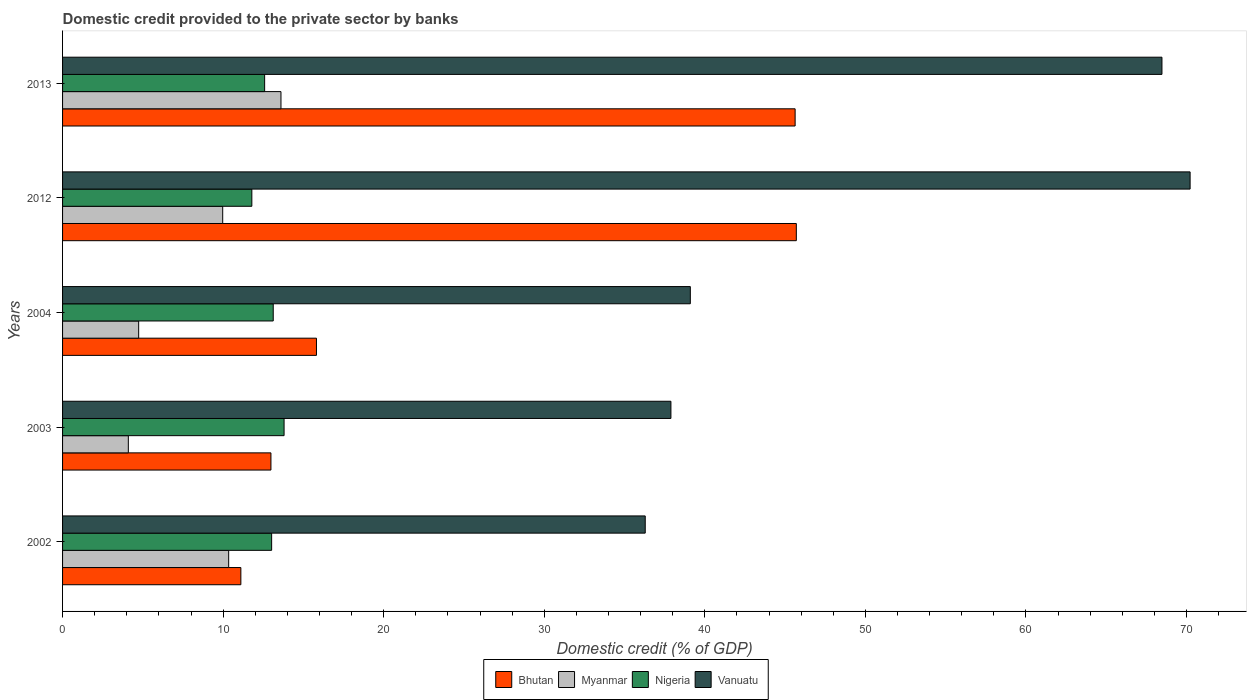How many different coloured bars are there?
Keep it short and to the point. 4. How many bars are there on the 1st tick from the top?
Provide a short and direct response. 4. What is the label of the 5th group of bars from the top?
Your response must be concise. 2002. What is the domestic credit provided to the private sector by banks in Nigeria in 2003?
Make the answer very short. 13.8. Across all years, what is the maximum domestic credit provided to the private sector by banks in Vanuatu?
Offer a very short reply. 70.22. Across all years, what is the minimum domestic credit provided to the private sector by banks in Bhutan?
Offer a very short reply. 11.1. In which year was the domestic credit provided to the private sector by banks in Nigeria maximum?
Give a very brief answer. 2003. In which year was the domestic credit provided to the private sector by banks in Nigeria minimum?
Your response must be concise. 2012. What is the total domestic credit provided to the private sector by banks in Nigeria in the graph?
Your answer should be compact. 64.31. What is the difference between the domestic credit provided to the private sector by banks in Myanmar in 2003 and that in 2012?
Offer a very short reply. -5.88. What is the difference between the domestic credit provided to the private sector by banks in Bhutan in 2013 and the domestic credit provided to the private sector by banks in Nigeria in 2002?
Offer a terse response. 32.6. What is the average domestic credit provided to the private sector by banks in Myanmar per year?
Offer a terse response. 8.55. In the year 2003, what is the difference between the domestic credit provided to the private sector by banks in Myanmar and domestic credit provided to the private sector by banks in Vanuatu?
Ensure brevity in your answer.  -33.79. What is the ratio of the domestic credit provided to the private sector by banks in Bhutan in 2003 to that in 2012?
Provide a succinct answer. 0.28. Is the difference between the domestic credit provided to the private sector by banks in Myanmar in 2002 and 2012 greater than the difference between the domestic credit provided to the private sector by banks in Vanuatu in 2002 and 2012?
Ensure brevity in your answer.  Yes. What is the difference between the highest and the second highest domestic credit provided to the private sector by banks in Myanmar?
Make the answer very short. 3.26. What is the difference between the highest and the lowest domestic credit provided to the private sector by banks in Nigeria?
Keep it short and to the point. 2.01. Is the sum of the domestic credit provided to the private sector by banks in Myanmar in 2004 and 2012 greater than the maximum domestic credit provided to the private sector by banks in Bhutan across all years?
Ensure brevity in your answer.  No. Is it the case that in every year, the sum of the domestic credit provided to the private sector by banks in Bhutan and domestic credit provided to the private sector by banks in Nigeria is greater than the sum of domestic credit provided to the private sector by banks in Vanuatu and domestic credit provided to the private sector by banks in Myanmar?
Provide a succinct answer. No. What does the 1st bar from the top in 2012 represents?
Provide a short and direct response. Vanuatu. What does the 4th bar from the bottom in 2003 represents?
Provide a succinct answer. Vanuatu. Are all the bars in the graph horizontal?
Keep it short and to the point. Yes. Does the graph contain any zero values?
Ensure brevity in your answer.  No. Where does the legend appear in the graph?
Offer a very short reply. Bottom center. How many legend labels are there?
Your response must be concise. 4. What is the title of the graph?
Give a very brief answer. Domestic credit provided to the private sector by banks. What is the label or title of the X-axis?
Your answer should be compact. Domestic credit (% of GDP). What is the Domestic credit (% of GDP) in Bhutan in 2002?
Ensure brevity in your answer.  11.1. What is the Domestic credit (% of GDP) in Myanmar in 2002?
Provide a succinct answer. 10.34. What is the Domestic credit (% of GDP) of Nigeria in 2002?
Make the answer very short. 13.02. What is the Domestic credit (% of GDP) in Vanuatu in 2002?
Provide a succinct answer. 36.29. What is the Domestic credit (% of GDP) in Bhutan in 2003?
Give a very brief answer. 12.98. What is the Domestic credit (% of GDP) in Myanmar in 2003?
Your answer should be compact. 4.1. What is the Domestic credit (% of GDP) of Nigeria in 2003?
Your response must be concise. 13.8. What is the Domestic credit (% of GDP) of Vanuatu in 2003?
Your answer should be very brief. 37.89. What is the Domestic credit (% of GDP) in Bhutan in 2004?
Keep it short and to the point. 15.81. What is the Domestic credit (% of GDP) of Myanmar in 2004?
Your answer should be very brief. 4.74. What is the Domestic credit (% of GDP) in Nigeria in 2004?
Provide a succinct answer. 13.12. What is the Domestic credit (% of GDP) of Vanuatu in 2004?
Keep it short and to the point. 39.1. What is the Domestic credit (% of GDP) of Bhutan in 2012?
Ensure brevity in your answer.  45.7. What is the Domestic credit (% of GDP) in Myanmar in 2012?
Offer a terse response. 9.97. What is the Domestic credit (% of GDP) in Nigeria in 2012?
Your response must be concise. 11.79. What is the Domestic credit (% of GDP) in Vanuatu in 2012?
Give a very brief answer. 70.22. What is the Domestic credit (% of GDP) in Bhutan in 2013?
Your answer should be very brief. 45.62. What is the Domestic credit (% of GDP) in Myanmar in 2013?
Offer a terse response. 13.6. What is the Domestic credit (% of GDP) in Nigeria in 2013?
Make the answer very short. 12.59. What is the Domestic credit (% of GDP) of Vanuatu in 2013?
Provide a succinct answer. 68.47. Across all years, what is the maximum Domestic credit (% of GDP) of Bhutan?
Your answer should be compact. 45.7. Across all years, what is the maximum Domestic credit (% of GDP) in Myanmar?
Offer a terse response. 13.6. Across all years, what is the maximum Domestic credit (% of GDP) of Nigeria?
Your answer should be very brief. 13.8. Across all years, what is the maximum Domestic credit (% of GDP) of Vanuatu?
Offer a terse response. 70.22. Across all years, what is the minimum Domestic credit (% of GDP) of Bhutan?
Offer a terse response. 11.1. Across all years, what is the minimum Domestic credit (% of GDP) in Myanmar?
Offer a terse response. 4.1. Across all years, what is the minimum Domestic credit (% of GDP) of Nigeria?
Offer a terse response. 11.79. Across all years, what is the minimum Domestic credit (% of GDP) in Vanuatu?
Your answer should be very brief. 36.29. What is the total Domestic credit (% of GDP) in Bhutan in the graph?
Offer a terse response. 131.22. What is the total Domestic credit (% of GDP) in Myanmar in the graph?
Your answer should be very brief. 42.76. What is the total Domestic credit (% of GDP) of Nigeria in the graph?
Your response must be concise. 64.31. What is the total Domestic credit (% of GDP) in Vanuatu in the graph?
Give a very brief answer. 251.97. What is the difference between the Domestic credit (% of GDP) in Bhutan in 2002 and that in 2003?
Provide a short and direct response. -1.87. What is the difference between the Domestic credit (% of GDP) in Myanmar in 2002 and that in 2003?
Your response must be concise. 6.25. What is the difference between the Domestic credit (% of GDP) in Nigeria in 2002 and that in 2003?
Keep it short and to the point. -0.78. What is the difference between the Domestic credit (% of GDP) of Vanuatu in 2002 and that in 2003?
Make the answer very short. -1.6. What is the difference between the Domestic credit (% of GDP) of Bhutan in 2002 and that in 2004?
Ensure brevity in your answer.  -4.71. What is the difference between the Domestic credit (% of GDP) in Myanmar in 2002 and that in 2004?
Make the answer very short. 5.6. What is the difference between the Domestic credit (% of GDP) in Nigeria in 2002 and that in 2004?
Make the answer very short. -0.1. What is the difference between the Domestic credit (% of GDP) of Vanuatu in 2002 and that in 2004?
Provide a short and direct response. -2.81. What is the difference between the Domestic credit (% of GDP) in Bhutan in 2002 and that in 2012?
Your answer should be very brief. -34.59. What is the difference between the Domestic credit (% of GDP) in Myanmar in 2002 and that in 2012?
Ensure brevity in your answer.  0.37. What is the difference between the Domestic credit (% of GDP) in Nigeria in 2002 and that in 2012?
Keep it short and to the point. 1.23. What is the difference between the Domestic credit (% of GDP) of Vanuatu in 2002 and that in 2012?
Make the answer very short. -33.94. What is the difference between the Domestic credit (% of GDP) of Bhutan in 2002 and that in 2013?
Your answer should be compact. -34.52. What is the difference between the Domestic credit (% of GDP) in Myanmar in 2002 and that in 2013?
Offer a terse response. -3.26. What is the difference between the Domestic credit (% of GDP) in Nigeria in 2002 and that in 2013?
Provide a succinct answer. 0.44. What is the difference between the Domestic credit (% of GDP) of Vanuatu in 2002 and that in 2013?
Give a very brief answer. -32.18. What is the difference between the Domestic credit (% of GDP) of Bhutan in 2003 and that in 2004?
Provide a short and direct response. -2.83. What is the difference between the Domestic credit (% of GDP) of Myanmar in 2003 and that in 2004?
Provide a short and direct response. -0.64. What is the difference between the Domestic credit (% of GDP) of Nigeria in 2003 and that in 2004?
Keep it short and to the point. 0.68. What is the difference between the Domestic credit (% of GDP) in Vanuatu in 2003 and that in 2004?
Provide a succinct answer. -1.21. What is the difference between the Domestic credit (% of GDP) of Bhutan in 2003 and that in 2012?
Keep it short and to the point. -32.72. What is the difference between the Domestic credit (% of GDP) of Myanmar in 2003 and that in 2012?
Provide a short and direct response. -5.88. What is the difference between the Domestic credit (% of GDP) in Nigeria in 2003 and that in 2012?
Your response must be concise. 2.01. What is the difference between the Domestic credit (% of GDP) in Vanuatu in 2003 and that in 2012?
Give a very brief answer. -32.34. What is the difference between the Domestic credit (% of GDP) in Bhutan in 2003 and that in 2013?
Ensure brevity in your answer.  -32.65. What is the difference between the Domestic credit (% of GDP) of Myanmar in 2003 and that in 2013?
Provide a short and direct response. -9.51. What is the difference between the Domestic credit (% of GDP) of Nigeria in 2003 and that in 2013?
Offer a very short reply. 1.21. What is the difference between the Domestic credit (% of GDP) in Vanuatu in 2003 and that in 2013?
Give a very brief answer. -30.58. What is the difference between the Domestic credit (% of GDP) in Bhutan in 2004 and that in 2012?
Your response must be concise. -29.89. What is the difference between the Domestic credit (% of GDP) of Myanmar in 2004 and that in 2012?
Offer a terse response. -5.23. What is the difference between the Domestic credit (% of GDP) of Nigeria in 2004 and that in 2012?
Provide a short and direct response. 1.33. What is the difference between the Domestic credit (% of GDP) of Vanuatu in 2004 and that in 2012?
Keep it short and to the point. -31.13. What is the difference between the Domestic credit (% of GDP) of Bhutan in 2004 and that in 2013?
Offer a terse response. -29.81. What is the difference between the Domestic credit (% of GDP) in Myanmar in 2004 and that in 2013?
Offer a terse response. -8.86. What is the difference between the Domestic credit (% of GDP) of Nigeria in 2004 and that in 2013?
Make the answer very short. 0.54. What is the difference between the Domestic credit (% of GDP) in Vanuatu in 2004 and that in 2013?
Provide a short and direct response. -29.37. What is the difference between the Domestic credit (% of GDP) of Bhutan in 2012 and that in 2013?
Offer a very short reply. 0.07. What is the difference between the Domestic credit (% of GDP) of Myanmar in 2012 and that in 2013?
Your answer should be very brief. -3.63. What is the difference between the Domestic credit (% of GDP) in Nigeria in 2012 and that in 2013?
Offer a very short reply. -0.8. What is the difference between the Domestic credit (% of GDP) in Vanuatu in 2012 and that in 2013?
Keep it short and to the point. 1.75. What is the difference between the Domestic credit (% of GDP) of Bhutan in 2002 and the Domestic credit (% of GDP) of Myanmar in 2003?
Offer a terse response. 7.01. What is the difference between the Domestic credit (% of GDP) of Bhutan in 2002 and the Domestic credit (% of GDP) of Nigeria in 2003?
Ensure brevity in your answer.  -2.69. What is the difference between the Domestic credit (% of GDP) of Bhutan in 2002 and the Domestic credit (% of GDP) of Vanuatu in 2003?
Offer a terse response. -26.78. What is the difference between the Domestic credit (% of GDP) of Myanmar in 2002 and the Domestic credit (% of GDP) of Nigeria in 2003?
Make the answer very short. -3.45. What is the difference between the Domestic credit (% of GDP) in Myanmar in 2002 and the Domestic credit (% of GDP) in Vanuatu in 2003?
Your answer should be very brief. -27.54. What is the difference between the Domestic credit (% of GDP) of Nigeria in 2002 and the Domestic credit (% of GDP) of Vanuatu in 2003?
Offer a very short reply. -24.87. What is the difference between the Domestic credit (% of GDP) in Bhutan in 2002 and the Domestic credit (% of GDP) in Myanmar in 2004?
Your answer should be very brief. 6.36. What is the difference between the Domestic credit (% of GDP) in Bhutan in 2002 and the Domestic credit (% of GDP) in Nigeria in 2004?
Offer a terse response. -2.02. What is the difference between the Domestic credit (% of GDP) of Bhutan in 2002 and the Domestic credit (% of GDP) of Vanuatu in 2004?
Provide a succinct answer. -27.99. What is the difference between the Domestic credit (% of GDP) of Myanmar in 2002 and the Domestic credit (% of GDP) of Nigeria in 2004?
Give a very brief answer. -2.78. What is the difference between the Domestic credit (% of GDP) of Myanmar in 2002 and the Domestic credit (% of GDP) of Vanuatu in 2004?
Make the answer very short. -28.75. What is the difference between the Domestic credit (% of GDP) of Nigeria in 2002 and the Domestic credit (% of GDP) of Vanuatu in 2004?
Provide a short and direct response. -26.08. What is the difference between the Domestic credit (% of GDP) in Bhutan in 2002 and the Domestic credit (% of GDP) in Myanmar in 2012?
Your answer should be compact. 1.13. What is the difference between the Domestic credit (% of GDP) of Bhutan in 2002 and the Domestic credit (% of GDP) of Nigeria in 2012?
Provide a short and direct response. -0.68. What is the difference between the Domestic credit (% of GDP) of Bhutan in 2002 and the Domestic credit (% of GDP) of Vanuatu in 2012?
Provide a succinct answer. -59.12. What is the difference between the Domestic credit (% of GDP) of Myanmar in 2002 and the Domestic credit (% of GDP) of Nigeria in 2012?
Make the answer very short. -1.44. What is the difference between the Domestic credit (% of GDP) of Myanmar in 2002 and the Domestic credit (% of GDP) of Vanuatu in 2012?
Your answer should be compact. -59.88. What is the difference between the Domestic credit (% of GDP) in Nigeria in 2002 and the Domestic credit (% of GDP) in Vanuatu in 2012?
Give a very brief answer. -57.2. What is the difference between the Domestic credit (% of GDP) in Bhutan in 2002 and the Domestic credit (% of GDP) in Myanmar in 2013?
Your response must be concise. -2.5. What is the difference between the Domestic credit (% of GDP) in Bhutan in 2002 and the Domestic credit (% of GDP) in Nigeria in 2013?
Offer a very short reply. -1.48. What is the difference between the Domestic credit (% of GDP) of Bhutan in 2002 and the Domestic credit (% of GDP) of Vanuatu in 2013?
Your response must be concise. -57.37. What is the difference between the Domestic credit (% of GDP) in Myanmar in 2002 and the Domestic credit (% of GDP) in Nigeria in 2013?
Your answer should be compact. -2.24. What is the difference between the Domestic credit (% of GDP) in Myanmar in 2002 and the Domestic credit (% of GDP) in Vanuatu in 2013?
Your response must be concise. -58.13. What is the difference between the Domestic credit (% of GDP) in Nigeria in 2002 and the Domestic credit (% of GDP) in Vanuatu in 2013?
Your answer should be very brief. -55.45. What is the difference between the Domestic credit (% of GDP) in Bhutan in 2003 and the Domestic credit (% of GDP) in Myanmar in 2004?
Your answer should be very brief. 8.24. What is the difference between the Domestic credit (% of GDP) in Bhutan in 2003 and the Domestic credit (% of GDP) in Nigeria in 2004?
Ensure brevity in your answer.  -0.14. What is the difference between the Domestic credit (% of GDP) in Bhutan in 2003 and the Domestic credit (% of GDP) in Vanuatu in 2004?
Your answer should be very brief. -26.12. What is the difference between the Domestic credit (% of GDP) of Myanmar in 2003 and the Domestic credit (% of GDP) of Nigeria in 2004?
Your response must be concise. -9.03. What is the difference between the Domestic credit (% of GDP) of Myanmar in 2003 and the Domestic credit (% of GDP) of Vanuatu in 2004?
Your response must be concise. -35. What is the difference between the Domestic credit (% of GDP) of Nigeria in 2003 and the Domestic credit (% of GDP) of Vanuatu in 2004?
Provide a succinct answer. -25.3. What is the difference between the Domestic credit (% of GDP) in Bhutan in 2003 and the Domestic credit (% of GDP) in Myanmar in 2012?
Offer a terse response. 3. What is the difference between the Domestic credit (% of GDP) in Bhutan in 2003 and the Domestic credit (% of GDP) in Nigeria in 2012?
Your answer should be compact. 1.19. What is the difference between the Domestic credit (% of GDP) in Bhutan in 2003 and the Domestic credit (% of GDP) in Vanuatu in 2012?
Offer a terse response. -57.25. What is the difference between the Domestic credit (% of GDP) in Myanmar in 2003 and the Domestic credit (% of GDP) in Nigeria in 2012?
Your answer should be very brief. -7.69. What is the difference between the Domestic credit (% of GDP) of Myanmar in 2003 and the Domestic credit (% of GDP) of Vanuatu in 2012?
Give a very brief answer. -66.13. What is the difference between the Domestic credit (% of GDP) of Nigeria in 2003 and the Domestic credit (% of GDP) of Vanuatu in 2012?
Offer a terse response. -56.43. What is the difference between the Domestic credit (% of GDP) of Bhutan in 2003 and the Domestic credit (% of GDP) of Myanmar in 2013?
Make the answer very short. -0.62. What is the difference between the Domestic credit (% of GDP) of Bhutan in 2003 and the Domestic credit (% of GDP) of Nigeria in 2013?
Offer a very short reply. 0.39. What is the difference between the Domestic credit (% of GDP) of Bhutan in 2003 and the Domestic credit (% of GDP) of Vanuatu in 2013?
Offer a terse response. -55.49. What is the difference between the Domestic credit (% of GDP) in Myanmar in 2003 and the Domestic credit (% of GDP) in Nigeria in 2013?
Give a very brief answer. -8.49. What is the difference between the Domestic credit (% of GDP) in Myanmar in 2003 and the Domestic credit (% of GDP) in Vanuatu in 2013?
Provide a short and direct response. -64.38. What is the difference between the Domestic credit (% of GDP) of Nigeria in 2003 and the Domestic credit (% of GDP) of Vanuatu in 2013?
Provide a short and direct response. -54.67. What is the difference between the Domestic credit (% of GDP) of Bhutan in 2004 and the Domestic credit (% of GDP) of Myanmar in 2012?
Offer a very short reply. 5.84. What is the difference between the Domestic credit (% of GDP) of Bhutan in 2004 and the Domestic credit (% of GDP) of Nigeria in 2012?
Provide a short and direct response. 4.02. What is the difference between the Domestic credit (% of GDP) of Bhutan in 2004 and the Domestic credit (% of GDP) of Vanuatu in 2012?
Your answer should be very brief. -54.41. What is the difference between the Domestic credit (% of GDP) of Myanmar in 2004 and the Domestic credit (% of GDP) of Nigeria in 2012?
Make the answer very short. -7.05. What is the difference between the Domestic credit (% of GDP) of Myanmar in 2004 and the Domestic credit (% of GDP) of Vanuatu in 2012?
Your answer should be very brief. -65.48. What is the difference between the Domestic credit (% of GDP) in Nigeria in 2004 and the Domestic credit (% of GDP) in Vanuatu in 2012?
Make the answer very short. -57.1. What is the difference between the Domestic credit (% of GDP) in Bhutan in 2004 and the Domestic credit (% of GDP) in Myanmar in 2013?
Make the answer very short. 2.21. What is the difference between the Domestic credit (% of GDP) in Bhutan in 2004 and the Domestic credit (% of GDP) in Nigeria in 2013?
Offer a very short reply. 3.23. What is the difference between the Domestic credit (% of GDP) in Bhutan in 2004 and the Domestic credit (% of GDP) in Vanuatu in 2013?
Your response must be concise. -52.66. What is the difference between the Domestic credit (% of GDP) in Myanmar in 2004 and the Domestic credit (% of GDP) in Nigeria in 2013?
Provide a short and direct response. -7.85. What is the difference between the Domestic credit (% of GDP) in Myanmar in 2004 and the Domestic credit (% of GDP) in Vanuatu in 2013?
Give a very brief answer. -63.73. What is the difference between the Domestic credit (% of GDP) in Nigeria in 2004 and the Domestic credit (% of GDP) in Vanuatu in 2013?
Make the answer very short. -55.35. What is the difference between the Domestic credit (% of GDP) in Bhutan in 2012 and the Domestic credit (% of GDP) in Myanmar in 2013?
Your response must be concise. 32.1. What is the difference between the Domestic credit (% of GDP) in Bhutan in 2012 and the Domestic credit (% of GDP) in Nigeria in 2013?
Provide a succinct answer. 33.11. What is the difference between the Domestic credit (% of GDP) in Bhutan in 2012 and the Domestic credit (% of GDP) in Vanuatu in 2013?
Give a very brief answer. -22.77. What is the difference between the Domestic credit (% of GDP) in Myanmar in 2012 and the Domestic credit (% of GDP) in Nigeria in 2013?
Give a very brief answer. -2.61. What is the difference between the Domestic credit (% of GDP) in Myanmar in 2012 and the Domestic credit (% of GDP) in Vanuatu in 2013?
Ensure brevity in your answer.  -58.5. What is the difference between the Domestic credit (% of GDP) of Nigeria in 2012 and the Domestic credit (% of GDP) of Vanuatu in 2013?
Your response must be concise. -56.68. What is the average Domestic credit (% of GDP) of Bhutan per year?
Provide a succinct answer. 26.24. What is the average Domestic credit (% of GDP) of Myanmar per year?
Your answer should be compact. 8.55. What is the average Domestic credit (% of GDP) in Nigeria per year?
Provide a succinct answer. 12.86. What is the average Domestic credit (% of GDP) in Vanuatu per year?
Give a very brief answer. 50.39. In the year 2002, what is the difference between the Domestic credit (% of GDP) of Bhutan and Domestic credit (% of GDP) of Myanmar?
Your answer should be compact. 0.76. In the year 2002, what is the difference between the Domestic credit (% of GDP) in Bhutan and Domestic credit (% of GDP) in Nigeria?
Provide a short and direct response. -1.92. In the year 2002, what is the difference between the Domestic credit (% of GDP) in Bhutan and Domestic credit (% of GDP) in Vanuatu?
Make the answer very short. -25.18. In the year 2002, what is the difference between the Domestic credit (% of GDP) of Myanmar and Domestic credit (% of GDP) of Nigeria?
Provide a succinct answer. -2.68. In the year 2002, what is the difference between the Domestic credit (% of GDP) in Myanmar and Domestic credit (% of GDP) in Vanuatu?
Offer a terse response. -25.94. In the year 2002, what is the difference between the Domestic credit (% of GDP) in Nigeria and Domestic credit (% of GDP) in Vanuatu?
Offer a very short reply. -23.27. In the year 2003, what is the difference between the Domestic credit (% of GDP) of Bhutan and Domestic credit (% of GDP) of Myanmar?
Offer a very short reply. 8.88. In the year 2003, what is the difference between the Domestic credit (% of GDP) in Bhutan and Domestic credit (% of GDP) in Nigeria?
Your answer should be very brief. -0.82. In the year 2003, what is the difference between the Domestic credit (% of GDP) of Bhutan and Domestic credit (% of GDP) of Vanuatu?
Make the answer very short. -24.91. In the year 2003, what is the difference between the Domestic credit (% of GDP) in Myanmar and Domestic credit (% of GDP) in Nigeria?
Make the answer very short. -9.7. In the year 2003, what is the difference between the Domestic credit (% of GDP) in Myanmar and Domestic credit (% of GDP) in Vanuatu?
Your response must be concise. -33.79. In the year 2003, what is the difference between the Domestic credit (% of GDP) in Nigeria and Domestic credit (% of GDP) in Vanuatu?
Make the answer very short. -24.09. In the year 2004, what is the difference between the Domestic credit (% of GDP) of Bhutan and Domestic credit (% of GDP) of Myanmar?
Provide a succinct answer. 11.07. In the year 2004, what is the difference between the Domestic credit (% of GDP) in Bhutan and Domestic credit (% of GDP) in Nigeria?
Provide a short and direct response. 2.69. In the year 2004, what is the difference between the Domestic credit (% of GDP) of Bhutan and Domestic credit (% of GDP) of Vanuatu?
Your response must be concise. -23.28. In the year 2004, what is the difference between the Domestic credit (% of GDP) of Myanmar and Domestic credit (% of GDP) of Nigeria?
Make the answer very short. -8.38. In the year 2004, what is the difference between the Domestic credit (% of GDP) in Myanmar and Domestic credit (% of GDP) in Vanuatu?
Make the answer very short. -34.36. In the year 2004, what is the difference between the Domestic credit (% of GDP) of Nigeria and Domestic credit (% of GDP) of Vanuatu?
Your answer should be compact. -25.98. In the year 2012, what is the difference between the Domestic credit (% of GDP) in Bhutan and Domestic credit (% of GDP) in Myanmar?
Offer a terse response. 35.73. In the year 2012, what is the difference between the Domestic credit (% of GDP) in Bhutan and Domestic credit (% of GDP) in Nigeria?
Offer a very short reply. 33.91. In the year 2012, what is the difference between the Domestic credit (% of GDP) of Bhutan and Domestic credit (% of GDP) of Vanuatu?
Ensure brevity in your answer.  -24.53. In the year 2012, what is the difference between the Domestic credit (% of GDP) of Myanmar and Domestic credit (% of GDP) of Nigeria?
Your response must be concise. -1.82. In the year 2012, what is the difference between the Domestic credit (% of GDP) in Myanmar and Domestic credit (% of GDP) in Vanuatu?
Your response must be concise. -60.25. In the year 2012, what is the difference between the Domestic credit (% of GDP) in Nigeria and Domestic credit (% of GDP) in Vanuatu?
Offer a terse response. -58.44. In the year 2013, what is the difference between the Domestic credit (% of GDP) in Bhutan and Domestic credit (% of GDP) in Myanmar?
Make the answer very short. 32.02. In the year 2013, what is the difference between the Domestic credit (% of GDP) of Bhutan and Domestic credit (% of GDP) of Nigeria?
Ensure brevity in your answer.  33.04. In the year 2013, what is the difference between the Domestic credit (% of GDP) in Bhutan and Domestic credit (% of GDP) in Vanuatu?
Your answer should be very brief. -22.85. In the year 2013, what is the difference between the Domestic credit (% of GDP) of Myanmar and Domestic credit (% of GDP) of Nigeria?
Ensure brevity in your answer.  1.02. In the year 2013, what is the difference between the Domestic credit (% of GDP) in Myanmar and Domestic credit (% of GDP) in Vanuatu?
Keep it short and to the point. -54.87. In the year 2013, what is the difference between the Domestic credit (% of GDP) of Nigeria and Domestic credit (% of GDP) of Vanuatu?
Ensure brevity in your answer.  -55.89. What is the ratio of the Domestic credit (% of GDP) of Bhutan in 2002 to that in 2003?
Offer a terse response. 0.86. What is the ratio of the Domestic credit (% of GDP) of Myanmar in 2002 to that in 2003?
Make the answer very short. 2.53. What is the ratio of the Domestic credit (% of GDP) of Nigeria in 2002 to that in 2003?
Your response must be concise. 0.94. What is the ratio of the Domestic credit (% of GDP) of Vanuatu in 2002 to that in 2003?
Give a very brief answer. 0.96. What is the ratio of the Domestic credit (% of GDP) in Bhutan in 2002 to that in 2004?
Your answer should be very brief. 0.7. What is the ratio of the Domestic credit (% of GDP) of Myanmar in 2002 to that in 2004?
Provide a succinct answer. 2.18. What is the ratio of the Domestic credit (% of GDP) in Vanuatu in 2002 to that in 2004?
Ensure brevity in your answer.  0.93. What is the ratio of the Domestic credit (% of GDP) of Bhutan in 2002 to that in 2012?
Your response must be concise. 0.24. What is the ratio of the Domestic credit (% of GDP) of Myanmar in 2002 to that in 2012?
Ensure brevity in your answer.  1.04. What is the ratio of the Domestic credit (% of GDP) in Nigeria in 2002 to that in 2012?
Make the answer very short. 1.1. What is the ratio of the Domestic credit (% of GDP) of Vanuatu in 2002 to that in 2012?
Make the answer very short. 0.52. What is the ratio of the Domestic credit (% of GDP) of Bhutan in 2002 to that in 2013?
Provide a short and direct response. 0.24. What is the ratio of the Domestic credit (% of GDP) in Myanmar in 2002 to that in 2013?
Your answer should be very brief. 0.76. What is the ratio of the Domestic credit (% of GDP) of Nigeria in 2002 to that in 2013?
Make the answer very short. 1.03. What is the ratio of the Domestic credit (% of GDP) in Vanuatu in 2002 to that in 2013?
Your answer should be very brief. 0.53. What is the ratio of the Domestic credit (% of GDP) of Bhutan in 2003 to that in 2004?
Make the answer very short. 0.82. What is the ratio of the Domestic credit (% of GDP) in Myanmar in 2003 to that in 2004?
Ensure brevity in your answer.  0.86. What is the ratio of the Domestic credit (% of GDP) of Nigeria in 2003 to that in 2004?
Provide a short and direct response. 1.05. What is the ratio of the Domestic credit (% of GDP) of Vanuatu in 2003 to that in 2004?
Keep it short and to the point. 0.97. What is the ratio of the Domestic credit (% of GDP) in Bhutan in 2003 to that in 2012?
Keep it short and to the point. 0.28. What is the ratio of the Domestic credit (% of GDP) in Myanmar in 2003 to that in 2012?
Your response must be concise. 0.41. What is the ratio of the Domestic credit (% of GDP) in Nigeria in 2003 to that in 2012?
Your response must be concise. 1.17. What is the ratio of the Domestic credit (% of GDP) in Vanuatu in 2003 to that in 2012?
Your answer should be very brief. 0.54. What is the ratio of the Domestic credit (% of GDP) of Bhutan in 2003 to that in 2013?
Your response must be concise. 0.28. What is the ratio of the Domestic credit (% of GDP) of Myanmar in 2003 to that in 2013?
Ensure brevity in your answer.  0.3. What is the ratio of the Domestic credit (% of GDP) in Nigeria in 2003 to that in 2013?
Your answer should be very brief. 1.1. What is the ratio of the Domestic credit (% of GDP) of Vanuatu in 2003 to that in 2013?
Your response must be concise. 0.55. What is the ratio of the Domestic credit (% of GDP) in Bhutan in 2004 to that in 2012?
Ensure brevity in your answer.  0.35. What is the ratio of the Domestic credit (% of GDP) of Myanmar in 2004 to that in 2012?
Your answer should be compact. 0.48. What is the ratio of the Domestic credit (% of GDP) in Nigeria in 2004 to that in 2012?
Make the answer very short. 1.11. What is the ratio of the Domestic credit (% of GDP) in Vanuatu in 2004 to that in 2012?
Provide a succinct answer. 0.56. What is the ratio of the Domestic credit (% of GDP) in Bhutan in 2004 to that in 2013?
Give a very brief answer. 0.35. What is the ratio of the Domestic credit (% of GDP) in Myanmar in 2004 to that in 2013?
Offer a very short reply. 0.35. What is the ratio of the Domestic credit (% of GDP) in Nigeria in 2004 to that in 2013?
Offer a very short reply. 1.04. What is the ratio of the Domestic credit (% of GDP) of Vanuatu in 2004 to that in 2013?
Offer a terse response. 0.57. What is the ratio of the Domestic credit (% of GDP) of Bhutan in 2012 to that in 2013?
Keep it short and to the point. 1. What is the ratio of the Domestic credit (% of GDP) of Myanmar in 2012 to that in 2013?
Offer a terse response. 0.73. What is the ratio of the Domestic credit (% of GDP) of Nigeria in 2012 to that in 2013?
Ensure brevity in your answer.  0.94. What is the ratio of the Domestic credit (% of GDP) in Vanuatu in 2012 to that in 2013?
Offer a very short reply. 1.03. What is the difference between the highest and the second highest Domestic credit (% of GDP) of Bhutan?
Your response must be concise. 0.07. What is the difference between the highest and the second highest Domestic credit (% of GDP) of Myanmar?
Make the answer very short. 3.26. What is the difference between the highest and the second highest Domestic credit (% of GDP) in Nigeria?
Make the answer very short. 0.68. What is the difference between the highest and the second highest Domestic credit (% of GDP) of Vanuatu?
Your answer should be compact. 1.75. What is the difference between the highest and the lowest Domestic credit (% of GDP) in Bhutan?
Ensure brevity in your answer.  34.59. What is the difference between the highest and the lowest Domestic credit (% of GDP) of Myanmar?
Offer a very short reply. 9.51. What is the difference between the highest and the lowest Domestic credit (% of GDP) in Nigeria?
Provide a succinct answer. 2.01. What is the difference between the highest and the lowest Domestic credit (% of GDP) in Vanuatu?
Offer a very short reply. 33.94. 